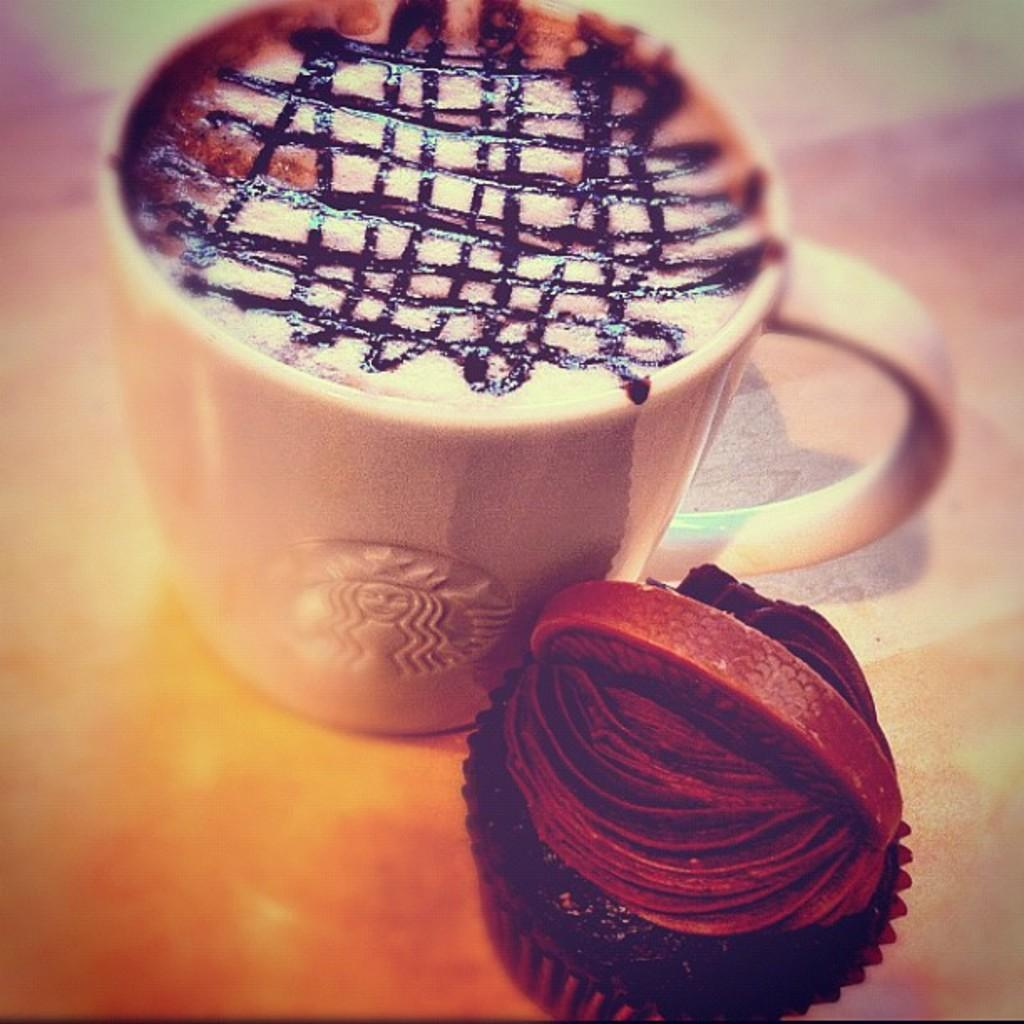What is in the cup that is visible in the image? There is a cup with coffee in the image. What other food item can be seen in the image? There is a muffin in the image. Where are the cup and muffin placed? The cup and muffin are placed on a surface. How would you describe the edges of the image? The borders of the image have a blurred view. How many eggs are visible in the image? There are no eggs present in the image. Is there a knee visible in the image? There is no knee visible in the image. 